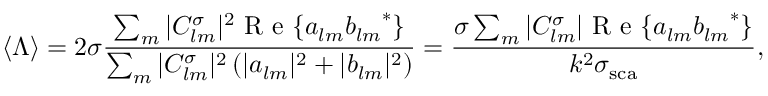<formula> <loc_0><loc_0><loc_500><loc_500>{ \langle \Lambda \rangle } = 2 \sigma \frac { \sum _ { m } | C _ { l m } ^ { \sigma } | ^ { 2 } R e \{ a _ { l m } { b _ { l m } } ^ { * } \} } { \sum _ { m } | C _ { l m } ^ { \sigma } | ^ { 2 } \left ( | a _ { l m } | ^ { 2 } + | b _ { l m } | ^ { 2 } \right ) } = \frac { \sigma \sum _ { m } | C _ { l m } ^ { \sigma } | R e \{ a _ { l m } { b _ { l m } } ^ { * } \} } { k ^ { 2 } \sigma _ { s c a } } ,</formula> 